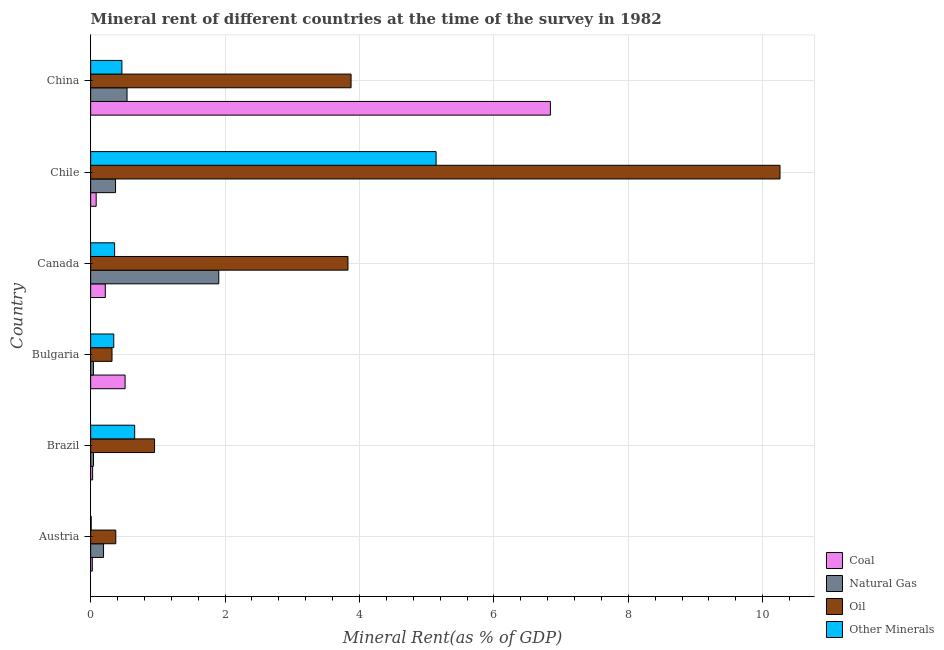How many groups of bars are there?
Keep it short and to the point. 6. Are the number of bars on each tick of the Y-axis equal?
Your answer should be compact. Yes. How many bars are there on the 1st tick from the top?
Your answer should be compact. 4. How many bars are there on the 3rd tick from the bottom?
Give a very brief answer. 4. What is the  rent of other minerals in Bulgaria?
Make the answer very short. 0.34. Across all countries, what is the maximum natural gas rent?
Your answer should be very brief. 1.91. Across all countries, what is the minimum coal rent?
Ensure brevity in your answer.  0.02. In which country was the coal rent maximum?
Keep it short and to the point. China. What is the total coal rent in the graph?
Your answer should be compact. 7.71. What is the difference between the coal rent in Austria and that in Canada?
Provide a short and direct response. -0.19. What is the difference between the oil rent in Brazil and the  rent of other minerals in Canada?
Provide a short and direct response. 0.59. What is the average coal rent per country?
Offer a very short reply. 1.28. What is the difference between the oil rent and coal rent in China?
Your answer should be very brief. -2.97. In how many countries, is the oil rent greater than 2 %?
Your answer should be compact. 3. What is the ratio of the  rent of other minerals in Austria to that in Chile?
Make the answer very short. 0. What is the difference between the highest and the second highest  rent of other minerals?
Your answer should be compact. 4.49. What is the difference between the highest and the lowest oil rent?
Offer a very short reply. 9.94. In how many countries, is the natural gas rent greater than the average natural gas rent taken over all countries?
Offer a terse response. 2. Is the sum of the natural gas rent in Austria and Chile greater than the maximum coal rent across all countries?
Provide a short and direct response. No. Is it the case that in every country, the sum of the oil rent and  rent of other minerals is greater than the sum of coal rent and natural gas rent?
Give a very brief answer. No. What does the 2nd bar from the top in Chile represents?
Ensure brevity in your answer.  Oil. What does the 1st bar from the bottom in Brazil represents?
Give a very brief answer. Coal. Is it the case that in every country, the sum of the coal rent and natural gas rent is greater than the oil rent?
Give a very brief answer. No. What is the difference between two consecutive major ticks on the X-axis?
Give a very brief answer. 2. Does the graph contain any zero values?
Offer a terse response. No. Where does the legend appear in the graph?
Provide a succinct answer. Bottom right. How many legend labels are there?
Ensure brevity in your answer.  4. How are the legend labels stacked?
Ensure brevity in your answer.  Vertical. What is the title of the graph?
Give a very brief answer. Mineral rent of different countries at the time of the survey in 1982. What is the label or title of the X-axis?
Your answer should be very brief. Mineral Rent(as % of GDP). What is the Mineral Rent(as % of GDP) of Coal in Austria?
Give a very brief answer. 0.02. What is the Mineral Rent(as % of GDP) of Natural Gas in Austria?
Give a very brief answer. 0.19. What is the Mineral Rent(as % of GDP) in Oil in Austria?
Your answer should be compact. 0.37. What is the Mineral Rent(as % of GDP) in Other Minerals in Austria?
Provide a succinct answer. 0.01. What is the Mineral Rent(as % of GDP) in Coal in Brazil?
Offer a terse response. 0.03. What is the Mineral Rent(as % of GDP) of Natural Gas in Brazil?
Make the answer very short. 0.04. What is the Mineral Rent(as % of GDP) in Oil in Brazil?
Provide a short and direct response. 0.95. What is the Mineral Rent(as % of GDP) of Other Minerals in Brazil?
Offer a terse response. 0.66. What is the Mineral Rent(as % of GDP) in Coal in Bulgaria?
Provide a succinct answer. 0.51. What is the Mineral Rent(as % of GDP) of Natural Gas in Bulgaria?
Provide a succinct answer. 0.04. What is the Mineral Rent(as % of GDP) in Oil in Bulgaria?
Offer a very short reply. 0.32. What is the Mineral Rent(as % of GDP) of Other Minerals in Bulgaria?
Give a very brief answer. 0.34. What is the Mineral Rent(as % of GDP) of Coal in Canada?
Your answer should be compact. 0.22. What is the Mineral Rent(as % of GDP) in Natural Gas in Canada?
Provide a short and direct response. 1.91. What is the Mineral Rent(as % of GDP) of Oil in Canada?
Offer a terse response. 3.83. What is the Mineral Rent(as % of GDP) of Other Minerals in Canada?
Provide a succinct answer. 0.36. What is the Mineral Rent(as % of GDP) of Coal in Chile?
Ensure brevity in your answer.  0.08. What is the Mineral Rent(as % of GDP) in Natural Gas in Chile?
Give a very brief answer. 0.37. What is the Mineral Rent(as % of GDP) of Oil in Chile?
Your answer should be compact. 10.26. What is the Mineral Rent(as % of GDP) in Other Minerals in Chile?
Your response must be concise. 5.14. What is the Mineral Rent(as % of GDP) of Coal in China?
Your answer should be very brief. 6.84. What is the Mineral Rent(as % of GDP) of Natural Gas in China?
Your response must be concise. 0.54. What is the Mineral Rent(as % of GDP) of Oil in China?
Your response must be concise. 3.87. What is the Mineral Rent(as % of GDP) in Other Minerals in China?
Make the answer very short. 0.47. Across all countries, what is the maximum Mineral Rent(as % of GDP) in Coal?
Provide a short and direct response. 6.84. Across all countries, what is the maximum Mineral Rent(as % of GDP) in Natural Gas?
Your answer should be very brief. 1.91. Across all countries, what is the maximum Mineral Rent(as % of GDP) in Oil?
Offer a very short reply. 10.26. Across all countries, what is the maximum Mineral Rent(as % of GDP) in Other Minerals?
Offer a terse response. 5.14. Across all countries, what is the minimum Mineral Rent(as % of GDP) of Coal?
Your answer should be very brief. 0.02. Across all countries, what is the minimum Mineral Rent(as % of GDP) in Natural Gas?
Make the answer very short. 0.04. Across all countries, what is the minimum Mineral Rent(as % of GDP) of Oil?
Your answer should be very brief. 0.32. Across all countries, what is the minimum Mineral Rent(as % of GDP) of Other Minerals?
Make the answer very short. 0.01. What is the total Mineral Rent(as % of GDP) in Coal in the graph?
Give a very brief answer. 7.71. What is the total Mineral Rent(as % of GDP) of Natural Gas in the graph?
Your answer should be compact. 3.09. What is the total Mineral Rent(as % of GDP) of Oil in the graph?
Give a very brief answer. 19.6. What is the total Mineral Rent(as % of GDP) of Other Minerals in the graph?
Offer a terse response. 6.97. What is the difference between the Mineral Rent(as % of GDP) of Coal in Austria and that in Brazil?
Offer a very short reply. -0. What is the difference between the Mineral Rent(as % of GDP) of Natural Gas in Austria and that in Brazil?
Make the answer very short. 0.15. What is the difference between the Mineral Rent(as % of GDP) of Oil in Austria and that in Brazil?
Provide a succinct answer. -0.58. What is the difference between the Mineral Rent(as % of GDP) in Other Minerals in Austria and that in Brazil?
Your response must be concise. -0.65. What is the difference between the Mineral Rent(as % of GDP) in Coal in Austria and that in Bulgaria?
Make the answer very short. -0.49. What is the difference between the Mineral Rent(as % of GDP) of Natural Gas in Austria and that in Bulgaria?
Provide a short and direct response. 0.15. What is the difference between the Mineral Rent(as % of GDP) of Oil in Austria and that in Bulgaria?
Ensure brevity in your answer.  0.06. What is the difference between the Mineral Rent(as % of GDP) of Other Minerals in Austria and that in Bulgaria?
Your answer should be very brief. -0.34. What is the difference between the Mineral Rent(as % of GDP) in Coal in Austria and that in Canada?
Provide a short and direct response. -0.19. What is the difference between the Mineral Rent(as % of GDP) in Natural Gas in Austria and that in Canada?
Keep it short and to the point. -1.71. What is the difference between the Mineral Rent(as % of GDP) of Oil in Austria and that in Canada?
Your response must be concise. -3.45. What is the difference between the Mineral Rent(as % of GDP) of Other Minerals in Austria and that in Canada?
Offer a terse response. -0.35. What is the difference between the Mineral Rent(as % of GDP) in Coal in Austria and that in Chile?
Offer a terse response. -0.06. What is the difference between the Mineral Rent(as % of GDP) in Natural Gas in Austria and that in Chile?
Give a very brief answer. -0.18. What is the difference between the Mineral Rent(as % of GDP) of Oil in Austria and that in Chile?
Offer a terse response. -9.88. What is the difference between the Mineral Rent(as % of GDP) in Other Minerals in Austria and that in Chile?
Your response must be concise. -5.13. What is the difference between the Mineral Rent(as % of GDP) in Coal in Austria and that in China?
Make the answer very short. -6.82. What is the difference between the Mineral Rent(as % of GDP) of Natural Gas in Austria and that in China?
Offer a terse response. -0.35. What is the difference between the Mineral Rent(as % of GDP) of Oil in Austria and that in China?
Your answer should be very brief. -3.5. What is the difference between the Mineral Rent(as % of GDP) in Other Minerals in Austria and that in China?
Provide a succinct answer. -0.46. What is the difference between the Mineral Rent(as % of GDP) in Coal in Brazil and that in Bulgaria?
Provide a succinct answer. -0.48. What is the difference between the Mineral Rent(as % of GDP) in Natural Gas in Brazil and that in Bulgaria?
Provide a short and direct response. 0. What is the difference between the Mineral Rent(as % of GDP) of Oil in Brazil and that in Bulgaria?
Your answer should be very brief. 0.63. What is the difference between the Mineral Rent(as % of GDP) in Other Minerals in Brazil and that in Bulgaria?
Ensure brevity in your answer.  0.31. What is the difference between the Mineral Rent(as % of GDP) of Coal in Brazil and that in Canada?
Provide a short and direct response. -0.19. What is the difference between the Mineral Rent(as % of GDP) of Natural Gas in Brazil and that in Canada?
Ensure brevity in your answer.  -1.86. What is the difference between the Mineral Rent(as % of GDP) in Oil in Brazil and that in Canada?
Your answer should be compact. -2.88. What is the difference between the Mineral Rent(as % of GDP) in Other Minerals in Brazil and that in Canada?
Provide a succinct answer. 0.3. What is the difference between the Mineral Rent(as % of GDP) in Coal in Brazil and that in Chile?
Your response must be concise. -0.05. What is the difference between the Mineral Rent(as % of GDP) of Natural Gas in Brazil and that in Chile?
Provide a succinct answer. -0.33. What is the difference between the Mineral Rent(as % of GDP) in Oil in Brazil and that in Chile?
Your answer should be compact. -9.31. What is the difference between the Mineral Rent(as % of GDP) in Other Minerals in Brazil and that in Chile?
Offer a very short reply. -4.49. What is the difference between the Mineral Rent(as % of GDP) in Coal in Brazil and that in China?
Ensure brevity in your answer.  -6.81. What is the difference between the Mineral Rent(as % of GDP) of Natural Gas in Brazil and that in China?
Provide a short and direct response. -0.5. What is the difference between the Mineral Rent(as % of GDP) in Oil in Brazil and that in China?
Offer a terse response. -2.92. What is the difference between the Mineral Rent(as % of GDP) of Other Minerals in Brazil and that in China?
Provide a short and direct response. 0.19. What is the difference between the Mineral Rent(as % of GDP) of Coal in Bulgaria and that in Canada?
Keep it short and to the point. 0.29. What is the difference between the Mineral Rent(as % of GDP) in Natural Gas in Bulgaria and that in Canada?
Your answer should be compact. -1.87. What is the difference between the Mineral Rent(as % of GDP) of Oil in Bulgaria and that in Canada?
Offer a very short reply. -3.51. What is the difference between the Mineral Rent(as % of GDP) of Other Minerals in Bulgaria and that in Canada?
Provide a succinct answer. -0.01. What is the difference between the Mineral Rent(as % of GDP) of Coal in Bulgaria and that in Chile?
Your answer should be compact. 0.43. What is the difference between the Mineral Rent(as % of GDP) of Natural Gas in Bulgaria and that in Chile?
Provide a succinct answer. -0.33. What is the difference between the Mineral Rent(as % of GDP) of Oil in Bulgaria and that in Chile?
Ensure brevity in your answer.  -9.94. What is the difference between the Mineral Rent(as % of GDP) in Other Minerals in Bulgaria and that in Chile?
Your response must be concise. -4.8. What is the difference between the Mineral Rent(as % of GDP) in Coal in Bulgaria and that in China?
Your answer should be compact. -6.33. What is the difference between the Mineral Rent(as % of GDP) of Natural Gas in Bulgaria and that in China?
Offer a terse response. -0.5. What is the difference between the Mineral Rent(as % of GDP) of Oil in Bulgaria and that in China?
Offer a very short reply. -3.56. What is the difference between the Mineral Rent(as % of GDP) of Other Minerals in Bulgaria and that in China?
Your answer should be compact. -0.12. What is the difference between the Mineral Rent(as % of GDP) in Coal in Canada and that in Chile?
Your response must be concise. 0.14. What is the difference between the Mineral Rent(as % of GDP) in Natural Gas in Canada and that in Chile?
Keep it short and to the point. 1.54. What is the difference between the Mineral Rent(as % of GDP) in Oil in Canada and that in Chile?
Provide a short and direct response. -6.43. What is the difference between the Mineral Rent(as % of GDP) in Other Minerals in Canada and that in Chile?
Your answer should be compact. -4.78. What is the difference between the Mineral Rent(as % of GDP) in Coal in Canada and that in China?
Offer a terse response. -6.62. What is the difference between the Mineral Rent(as % of GDP) in Natural Gas in Canada and that in China?
Keep it short and to the point. 1.36. What is the difference between the Mineral Rent(as % of GDP) of Oil in Canada and that in China?
Your response must be concise. -0.05. What is the difference between the Mineral Rent(as % of GDP) of Other Minerals in Canada and that in China?
Your answer should be compact. -0.11. What is the difference between the Mineral Rent(as % of GDP) of Coal in Chile and that in China?
Your answer should be compact. -6.76. What is the difference between the Mineral Rent(as % of GDP) in Natural Gas in Chile and that in China?
Ensure brevity in your answer.  -0.17. What is the difference between the Mineral Rent(as % of GDP) of Oil in Chile and that in China?
Ensure brevity in your answer.  6.38. What is the difference between the Mineral Rent(as % of GDP) of Other Minerals in Chile and that in China?
Offer a very short reply. 4.68. What is the difference between the Mineral Rent(as % of GDP) of Coal in Austria and the Mineral Rent(as % of GDP) of Natural Gas in Brazil?
Provide a succinct answer. -0.02. What is the difference between the Mineral Rent(as % of GDP) in Coal in Austria and the Mineral Rent(as % of GDP) in Oil in Brazil?
Make the answer very short. -0.93. What is the difference between the Mineral Rent(as % of GDP) in Coal in Austria and the Mineral Rent(as % of GDP) in Other Minerals in Brazil?
Your response must be concise. -0.63. What is the difference between the Mineral Rent(as % of GDP) of Natural Gas in Austria and the Mineral Rent(as % of GDP) of Oil in Brazil?
Provide a short and direct response. -0.76. What is the difference between the Mineral Rent(as % of GDP) of Natural Gas in Austria and the Mineral Rent(as % of GDP) of Other Minerals in Brazil?
Offer a terse response. -0.46. What is the difference between the Mineral Rent(as % of GDP) in Oil in Austria and the Mineral Rent(as % of GDP) in Other Minerals in Brazil?
Your response must be concise. -0.28. What is the difference between the Mineral Rent(as % of GDP) of Coal in Austria and the Mineral Rent(as % of GDP) of Natural Gas in Bulgaria?
Provide a short and direct response. -0.02. What is the difference between the Mineral Rent(as % of GDP) of Coal in Austria and the Mineral Rent(as % of GDP) of Oil in Bulgaria?
Provide a succinct answer. -0.29. What is the difference between the Mineral Rent(as % of GDP) of Coal in Austria and the Mineral Rent(as % of GDP) of Other Minerals in Bulgaria?
Provide a short and direct response. -0.32. What is the difference between the Mineral Rent(as % of GDP) in Natural Gas in Austria and the Mineral Rent(as % of GDP) in Oil in Bulgaria?
Ensure brevity in your answer.  -0.13. What is the difference between the Mineral Rent(as % of GDP) of Natural Gas in Austria and the Mineral Rent(as % of GDP) of Other Minerals in Bulgaria?
Offer a very short reply. -0.15. What is the difference between the Mineral Rent(as % of GDP) in Oil in Austria and the Mineral Rent(as % of GDP) in Other Minerals in Bulgaria?
Give a very brief answer. 0.03. What is the difference between the Mineral Rent(as % of GDP) of Coal in Austria and the Mineral Rent(as % of GDP) of Natural Gas in Canada?
Ensure brevity in your answer.  -1.88. What is the difference between the Mineral Rent(as % of GDP) of Coal in Austria and the Mineral Rent(as % of GDP) of Oil in Canada?
Your answer should be compact. -3.8. What is the difference between the Mineral Rent(as % of GDP) in Coal in Austria and the Mineral Rent(as % of GDP) in Other Minerals in Canada?
Ensure brevity in your answer.  -0.33. What is the difference between the Mineral Rent(as % of GDP) in Natural Gas in Austria and the Mineral Rent(as % of GDP) in Oil in Canada?
Provide a succinct answer. -3.64. What is the difference between the Mineral Rent(as % of GDP) in Natural Gas in Austria and the Mineral Rent(as % of GDP) in Other Minerals in Canada?
Provide a short and direct response. -0.16. What is the difference between the Mineral Rent(as % of GDP) of Oil in Austria and the Mineral Rent(as % of GDP) of Other Minerals in Canada?
Ensure brevity in your answer.  0.02. What is the difference between the Mineral Rent(as % of GDP) in Coal in Austria and the Mineral Rent(as % of GDP) in Natural Gas in Chile?
Provide a short and direct response. -0.35. What is the difference between the Mineral Rent(as % of GDP) of Coal in Austria and the Mineral Rent(as % of GDP) of Oil in Chile?
Provide a short and direct response. -10.23. What is the difference between the Mineral Rent(as % of GDP) in Coal in Austria and the Mineral Rent(as % of GDP) in Other Minerals in Chile?
Offer a terse response. -5.12. What is the difference between the Mineral Rent(as % of GDP) of Natural Gas in Austria and the Mineral Rent(as % of GDP) of Oil in Chile?
Provide a short and direct response. -10.07. What is the difference between the Mineral Rent(as % of GDP) in Natural Gas in Austria and the Mineral Rent(as % of GDP) in Other Minerals in Chile?
Offer a very short reply. -4.95. What is the difference between the Mineral Rent(as % of GDP) in Oil in Austria and the Mineral Rent(as % of GDP) in Other Minerals in Chile?
Offer a very short reply. -4.77. What is the difference between the Mineral Rent(as % of GDP) of Coal in Austria and the Mineral Rent(as % of GDP) of Natural Gas in China?
Make the answer very short. -0.52. What is the difference between the Mineral Rent(as % of GDP) in Coal in Austria and the Mineral Rent(as % of GDP) in Oil in China?
Your answer should be very brief. -3.85. What is the difference between the Mineral Rent(as % of GDP) of Coal in Austria and the Mineral Rent(as % of GDP) of Other Minerals in China?
Your response must be concise. -0.44. What is the difference between the Mineral Rent(as % of GDP) of Natural Gas in Austria and the Mineral Rent(as % of GDP) of Oil in China?
Provide a short and direct response. -3.68. What is the difference between the Mineral Rent(as % of GDP) in Natural Gas in Austria and the Mineral Rent(as % of GDP) in Other Minerals in China?
Provide a short and direct response. -0.27. What is the difference between the Mineral Rent(as % of GDP) of Oil in Austria and the Mineral Rent(as % of GDP) of Other Minerals in China?
Your response must be concise. -0.09. What is the difference between the Mineral Rent(as % of GDP) in Coal in Brazil and the Mineral Rent(as % of GDP) in Natural Gas in Bulgaria?
Offer a terse response. -0.01. What is the difference between the Mineral Rent(as % of GDP) of Coal in Brazil and the Mineral Rent(as % of GDP) of Oil in Bulgaria?
Your answer should be compact. -0.29. What is the difference between the Mineral Rent(as % of GDP) of Coal in Brazil and the Mineral Rent(as % of GDP) of Other Minerals in Bulgaria?
Your response must be concise. -0.31. What is the difference between the Mineral Rent(as % of GDP) of Natural Gas in Brazil and the Mineral Rent(as % of GDP) of Oil in Bulgaria?
Your answer should be compact. -0.28. What is the difference between the Mineral Rent(as % of GDP) in Natural Gas in Brazil and the Mineral Rent(as % of GDP) in Other Minerals in Bulgaria?
Ensure brevity in your answer.  -0.3. What is the difference between the Mineral Rent(as % of GDP) in Oil in Brazil and the Mineral Rent(as % of GDP) in Other Minerals in Bulgaria?
Offer a terse response. 0.61. What is the difference between the Mineral Rent(as % of GDP) in Coal in Brazil and the Mineral Rent(as % of GDP) in Natural Gas in Canada?
Ensure brevity in your answer.  -1.88. What is the difference between the Mineral Rent(as % of GDP) of Coal in Brazil and the Mineral Rent(as % of GDP) of Oil in Canada?
Keep it short and to the point. -3.8. What is the difference between the Mineral Rent(as % of GDP) of Coal in Brazil and the Mineral Rent(as % of GDP) of Other Minerals in Canada?
Offer a very short reply. -0.33. What is the difference between the Mineral Rent(as % of GDP) in Natural Gas in Brazil and the Mineral Rent(as % of GDP) in Oil in Canada?
Make the answer very short. -3.79. What is the difference between the Mineral Rent(as % of GDP) of Natural Gas in Brazil and the Mineral Rent(as % of GDP) of Other Minerals in Canada?
Your answer should be very brief. -0.31. What is the difference between the Mineral Rent(as % of GDP) of Oil in Brazil and the Mineral Rent(as % of GDP) of Other Minerals in Canada?
Give a very brief answer. 0.59. What is the difference between the Mineral Rent(as % of GDP) of Coal in Brazil and the Mineral Rent(as % of GDP) of Natural Gas in Chile?
Provide a succinct answer. -0.34. What is the difference between the Mineral Rent(as % of GDP) of Coal in Brazil and the Mineral Rent(as % of GDP) of Oil in Chile?
Offer a very short reply. -10.23. What is the difference between the Mineral Rent(as % of GDP) of Coal in Brazil and the Mineral Rent(as % of GDP) of Other Minerals in Chile?
Give a very brief answer. -5.11. What is the difference between the Mineral Rent(as % of GDP) in Natural Gas in Brazil and the Mineral Rent(as % of GDP) in Oil in Chile?
Your answer should be very brief. -10.21. What is the difference between the Mineral Rent(as % of GDP) of Natural Gas in Brazil and the Mineral Rent(as % of GDP) of Other Minerals in Chile?
Make the answer very short. -5.1. What is the difference between the Mineral Rent(as % of GDP) in Oil in Brazil and the Mineral Rent(as % of GDP) in Other Minerals in Chile?
Provide a short and direct response. -4.19. What is the difference between the Mineral Rent(as % of GDP) in Coal in Brazil and the Mineral Rent(as % of GDP) in Natural Gas in China?
Offer a terse response. -0.51. What is the difference between the Mineral Rent(as % of GDP) in Coal in Brazil and the Mineral Rent(as % of GDP) in Oil in China?
Keep it short and to the point. -3.85. What is the difference between the Mineral Rent(as % of GDP) of Coal in Brazil and the Mineral Rent(as % of GDP) of Other Minerals in China?
Ensure brevity in your answer.  -0.44. What is the difference between the Mineral Rent(as % of GDP) of Natural Gas in Brazil and the Mineral Rent(as % of GDP) of Oil in China?
Your answer should be very brief. -3.83. What is the difference between the Mineral Rent(as % of GDP) of Natural Gas in Brazil and the Mineral Rent(as % of GDP) of Other Minerals in China?
Make the answer very short. -0.42. What is the difference between the Mineral Rent(as % of GDP) in Oil in Brazil and the Mineral Rent(as % of GDP) in Other Minerals in China?
Ensure brevity in your answer.  0.49. What is the difference between the Mineral Rent(as % of GDP) of Coal in Bulgaria and the Mineral Rent(as % of GDP) of Natural Gas in Canada?
Keep it short and to the point. -1.39. What is the difference between the Mineral Rent(as % of GDP) of Coal in Bulgaria and the Mineral Rent(as % of GDP) of Oil in Canada?
Provide a short and direct response. -3.32. What is the difference between the Mineral Rent(as % of GDP) of Coal in Bulgaria and the Mineral Rent(as % of GDP) of Other Minerals in Canada?
Your answer should be compact. 0.16. What is the difference between the Mineral Rent(as % of GDP) of Natural Gas in Bulgaria and the Mineral Rent(as % of GDP) of Oil in Canada?
Your answer should be compact. -3.79. What is the difference between the Mineral Rent(as % of GDP) in Natural Gas in Bulgaria and the Mineral Rent(as % of GDP) in Other Minerals in Canada?
Keep it short and to the point. -0.32. What is the difference between the Mineral Rent(as % of GDP) in Oil in Bulgaria and the Mineral Rent(as % of GDP) in Other Minerals in Canada?
Offer a terse response. -0.04. What is the difference between the Mineral Rent(as % of GDP) of Coal in Bulgaria and the Mineral Rent(as % of GDP) of Natural Gas in Chile?
Give a very brief answer. 0.14. What is the difference between the Mineral Rent(as % of GDP) in Coal in Bulgaria and the Mineral Rent(as % of GDP) in Oil in Chile?
Your response must be concise. -9.74. What is the difference between the Mineral Rent(as % of GDP) of Coal in Bulgaria and the Mineral Rent(as % of GDP) of Other Minerals in Chile?
Provide a short and direct response. -4.63. What is the difference between the Mineral Rent(as % of GDP) in Natural Gas in Bulgaria and the Mineral Rent(as % of GDP) in Oil in Chile?
Keep it short and to the point. -10.22. What is the difference between the Mineral Rent(as % of GDP) in Natural Gas in Bulgaria and the Mineral Rent(as % of GDP) in Other Minerals in Chile?
Provide a short and direct response. -5.1. What is the difference between the Mineral Rent(as % of GDP) of Oil in Bulgaria and the Mineral Rent(as % of GDP) of Other Minerals in Chile?
Your answer should be compact. -4.82. What is the difference between the Mineral Rent(as % of GDP) in Coal in Bulgaria and the Mineral Rent(as % of GDP) in Natural Gas in China?
Keep it short and to the point. -0.03. What is the difference between the Mineral Rent(as % of GDP) of Coal in Bulgaria and the Mineral Rent(as % of GDP) of Oil in China?
Your answer should be compact. -3.36. What is the difference between the Mineral Rent(as % of GDP) in Coal in Bulgaria and the Mineral Rent(as % of GDP) in Other Minerals in China?
Your answer should be compact. 0.05. What is the difference between the Mineral Rent(as % of GDP) in Natural Gas in Bulgaria and the Mineral Rent(as % of GDP) in Oil in China?
Provide a succinct answer. -3.83. What is the difference between the Mineral Rent(as % of GDP) in Natural Gas in Bulgaria and the Mineral Rent(as % of GDP) in Other Minerals in China?
Provide a short and direct response. -0.42. What is the difference between the Mineral Rent(as % of GDP) of Oil in Bulgaria and the Mineral Rent(as % of GDP) of Other Minerals in China?
Your response must be concise. -0.15. What is the difference between the Mineral Rent(as % of GDP) in Coal in Canada and the Mineral Rent(as % of GDP) in Natural Gas in Chile?
Offer a terse response. -0.15. What is the difference between the Mineral Rent(as % of GDP) of Coal in Canada and the Mineral Rent(as % of GDP) of Oil in Chile?
Ensure brevity in your answer.  -10.04. What is the difference between the Mineral Rent(as % of GDP) in Coal in Canada and the Mineral Rent(as % of GDP) in Other Minerals in Chile?
Offer a very short reply. -4.92. What is the difference between the Mineral Rent(as % of GDP) of Natural Gas in Canada and the Mineral Rent(as % of GDP) of Oil in Chile?
Offer a terse response. -8.35. What is the difference between the Mineral Rent(as % of GDP) in Natural Gas in Canada and the Mineral Rent(as % of GDP) in Other Minerals in Chile?
Keep it short and to the point. -3.23. What is the difference between the Mineral Rent(as % of GDP) in Oil in Canada and the Mineral Rent(as % of GDP) in Other Minerals in Chile?
Provide a succinct answer. -1.31. What is the difference between the Mineral Rent(as % of GDP) of Coal in Canada and the Mineral Rent(as % of GDP) of Natural Gas in China?
Give a very brief answer. -0.32. What is the difference between the Mineral Rent(as % of GDP) in Coal in Canada and the Mineral Rent(as % of GDP) in Oil in China?
Give a very brief answer. -3.66. What is the difference between the Mineral Rent(as % of GDP) in Coal in Canada and the Mineral Rent(as % of GDP) in Other Minerals in China?
Your answer should be compact. -0.25. What is the difference between the Mineral Rent(as % of GDP) in Natural Gas in Canada and the Mineral Rent(as % of GDP) in Oil in China?
Your answer should be very brief. -1.97. What is the difference between the Mineral Rent(as % of GDP) in Natural Gas in Canada and the Mineral Rent(as % of GDP) in Other Minerals in China?
Provide a succinct answer. 1.44. What is the difference between the Mineral Rent(as % of GDP) in Oil in Canada and the Mineral Rent(as % of GDP) in Other Minerals in China?
Provide a succinct answer. 3.36. What is the difference between the Mineral Rent(as % of GDP) in Coal in Chile and the Mineral Rent(as % of GDP) in Natural Gas in China?
Your answer should be compact. -0.46. What is the difference between the Mineral Rent(as % of GDP) in Coal in Chile and the Mineral Rent(as % of GDP) in Oil in China?
Your answer should be very brief. -3.79. What is the difference between the Mineral Rent(as % of GDP) in Coal in Chile and the Mineral Rent(as % of GDP) in Other Minerals in China?
Give a very brief answer. -0.38. What is the difference between the Mineral Rent(as % of GDP) in Natural Gas in Chile and the Mineral Rent(as % of GDP) in Oil in China?
Offer a very short reply. -3.5. What is the difference between the Mineral Rent(as % of GDP) of Natural Gas in Chile and the Mineral Rent(as % of GDP) of Other Minerals in China?
Offer a very short reply. -0.09. What is the difference between the Mineral Rent(as % of GDP) in Oil in Chile and the Mineral Rent(as % of GDP) in Other Minerals in China?
Your answer should be very brief. 9.79. What is the average Mineral Rent(as % of GDP) of Coal per country?
Provide a succinct answer. 1.28. What is the average Mineral Rent(as % of GDP) in Natural Gas per country?
Ensure brevity in your answer.  0.52. What is the average Mineral Rent(as % of GDP) of Oil per country?
Your answer should be compact. 3.27. What is the average Mineral Rent(as % of GDP) in Other Minerals per country?
Provide a short and direct response. 1.16. What is the difference between the Mineral Rent(as % of GDP) of Coal and Mineral Rent(as % of GDP) of Natural Gas in Austria?
Your answer should be very brief. -0.17. What is the difference between the Mineral Rent(as % of GDP) of Coal and Mineral Rent(as % of GDP) of Oil in Austria?
Provide a succinct answer. -0.35. What is the difference between the Mineral Rent(as % of GDP) in Coal and Mineral Rent(as % of GDP) in Other Minerals in Austria?
Ensure brevity in your answer.  0.02. What is the difference between the Mineral Rent(as % of GDP) of Natural Gas and Mineral Rent(as % of GDP) of Oil in Austria?
Keep it short and to the point. -0.18. What is the difference between the Mineral Rent(as % of GDP) of Natural Gas and Mineral Rent(as % of GDP) of Other Minerals in Austria?
Make the answer very short. 0.18. What is the difference between the Mineral Rent(as % of GDP) of Oil and Mineral Rent(as % of GDP) of Other Minerals in Austria?
Ensure brevity in your answer.  0.37. What is the difference between the Mineral Rent(as % of GDP) in Coal and Mineral Rent(as % of GDP) in Natural Gas in Brazil?
Give a very brief answer. -0.01. What is the difference between the Mineral Rent(as % of GDP) in Coal and Mineral Rent(as % of GDP) in Oil in Brazil?
Give a very brief answer. -0.92. What is the difference between the Mineral Rent(as % of GDP) in Coal and Mineral Rent(as % of GDP) in Other Minerals in Brazil?
Ensure brevity in your answer.  -0.63. What is the difference between the Mineral Rent(as % of GDP) of Natural Gas and Mineral Rent(as % of GDP) of Oil in Brazil?
Keep it short and to the point. -0.91. What is the difference between the Mineral Rent(as % of GDP) of Natural Gas and Mineral Rent(as % of GDP) of Other Minerals in Brazil?
Your answer should be compact. -0.61. What is the difference between the Mineral Rent(as % of GDP) of Oil and Mineral Rent(as % of GDP) of Other Minerals in Brazil?
Offer a terse response. 0.3. What is the difference between the Mineral Rent(as % of GDP) of Coal and Mineral Rent(as % of GDP) of Natural Gas in Bulgaria?
Your answer should be very brief. 0.47. What is the difference between the Mineral Rent(as % of GDP) of Coal and Mineral Rent(as % of GDP) of Oil in Bulgaria?
Your answer should be compact. 0.19. What is the difference between the Mineral Rent(as % of GDP) of Coal and Mineral Rent(as % of GDP) of Other Minerals in Bulgaria?
Make the answer very short. 0.17. What is the difference between the Mineral Rent(as % of GDP) in Natural Gas and Mineral Rent(as % of GDP) in Oil in Bulgaria?
Keep it short and to the point. -0.28. What is the difference between the Mineral Rent(as % of GDP) of Natural Gas and Mineral Rent(as % of GDP) of Other Minerals in Bulgaria?
Make the answer very short. -0.3. What is the difference between the Mineral Rent(as % of GDP) of Oil and Mineral Rent(as % of GDP) of Other Minerals in Bulgaria?
Ensure brevity in your answer.  -0.03. What is the difference between the Mineral Rent(as % of GDP) in Coal and Mineral Rent(as % of GDP) in Natural Gas in Canada?
Ensure brevity in your answer.  -1.69. What is the difference between the Mineral Rent(as % of GDP) of Coal and Mineral Rent(as % of GDP) of Oil in Canada?
Provide a succinct answer. -3.61. What is the difference between the Mineral Rent(as % of GDP) in Coal and Mineral Rent(as % of GDP) in Other Minerals in Canada?
Provide a succinct answer. -0.14. What is the difference between the Mineral Rent(as % of GDP) in Natural Gas and Mineral Rent(as % of GDP) in Oil in Canada?
Your answer should be compact. -1.92. What is the difference between the Mineral Rent(as % of GDP) of Natural Gas and Mineral Rent(as % of GDP) of Other Minerals in Canada?
Give a very brief answer. 1.55. What is the difference between the Mineral Rent(as % of GDP) in Oil and Mineral Rent(as % of GDP) in Other Minerals in Canada?
Offer a very short reply. 3.47. What is the difference between the Mineral Rent(as % of GDP) of Coal and Mineral Rent(as % of GDP) of Natural Gas in Chile?
Keep it short and to the point. -0.29. What is the difference between the Mineral Rent(as % of GDP) of Coal and Mineral Rent(as % of GDP) of Oil in Chile?
Ensure brevity in your answer.  -10.18. What is the difference between the Mineral Rent(as % of GDP) of Coal and Mineral Rent(as % of GDP) of Other Minerals in Chile?
Make the answer very short. -5.06. What is the difference between the Mineral Rent(as % of GDP) of Natural Gas and Mineral Rent(as % of GDP) of Oil in Chile?
Your answer should be compact. -9.89. What is the difference between the Mineral Rent(as % of GDP) of Natural Gas and Mineral Rent(as % of GDP) of Other Minerals in Chile?
Keep it short and to the point. -4.77. What is the difference between the Mineral Rent(as % of GDP) of Oil and Mineral Rent(as % of GDP) of Other Minerals in Chile?
Make the answer very short. 5.12. What is the difference between the Mineral Rent(as % of GDP) in Coal and Mineral Rent(as % of GDP) in Natural Gas in China?
Your answer should be compact. 6.3. What is the difference between the Mineral Rent(as % of GDP) of Coal and Mineral Rent(as % of GDP) of Oil in China?
Provide a short and direct response. 2.97. What is the difference between the Mineral Rent(as % of GDP) in Coal and Mineral Rent(as % of GDP) in Other Minerals in China?
Ensure brevity in your answer.  6.38. What is the difference between the Mineral Rent(as % of GDP) of Natural Gas and Mineral Rent(as % of GDP) of Oil in China?
Your response must be concise. -3.33. What is the difference between the Mineral Rent(as % of GDP) of Natural Gas and Mineral Rent(as % of GDP) of Other Minerals in China?
Your answer should be compact. 0.08. What is the difference between the Mineral Rent(as % of GDP) of Oil and Mineral Rent(as % of GDP) of Other Minerals in China?
Give a very brief answer. 3.41. What is the ratio of the Mineral Rent(as % of GDP) in Coal in Austria to that in Brazil?
Provide a short and direct response. 0.84. What is the ratio of the Mineral Rent(as % of GDP) in Natural Gas in Austria to that in Brazil?
Give a very brief answer. 4.52. What is the ratio of the Mineral Rent(as % of GDP) in Oil in Austria to that in Brazil?
Ensure brevity in your answer.  0.39. What is the ratio of the Mineral Rent(as % of GDP) of Other Minerals in Austria to that in Brazil?
Give a very brief answer. 0.01. What is the ratio of the Mineral Rent(as % of GDP) of Coal in Austria to that in Bulgaria?
Provide a short and direct response. 0.05. What is the ratio of the Mineral Rent(as % of GDP) in Natural Gas in Austria to that in Bulgaria?
Ensure brevity in your answer.  4.67. What is the ratio of the Mineral Rent(as % of GDP) of Oil in Austria to that in Bulgaria?
Keep it short and to the point. 1.18. What is the ratio of the Mineral Rent(as % of GDP) of Other Minerals in Austria to that in Bulgaria?
Give a very brief answer. 0.02. What is the ratio of the Mineral Rent(as % of GDP) in Coal in Austria to that in Canada?
Give a very brief answer. 0.11. What is the ratio of the Mineral Rent(as % of GDP) of Natural Gas in Austria to that in Canada?
Make the answer very short. 0.1. What is the ratio of the Mineral Rent(as % of GDP) in Oil in Austria to that in Canada?
Give a very brief answer. 0.1. What is the ratio of the Mineral Rent(as % of GDP) in Other Minerals in Austria to that in Canada?
Ensure brevity in your answer.  0.02. What is the ratio of the Mineral Rent(as % of GDP) in Natural Gas in Austria to that in Chile?
Provide a short and direct response. 0.52. What is the ratio of the Mineral Rent(as % of GDP) of Oil in Austria to that in Chile?
Ensure brevity in your answer.  0.04. What is the ratio of the Mineral Rent(as % of GDP) in Other Minerals in Austria to that in Chile?
Give a very brief answer. 0. What is the ratio of the Mineral Rent(as % of GDP) in Coal in Austria to that in China?
Give a very brief answer. 0. What is the ratio of the Mineral Rent(as % of GDP) in Natural Gas in Austria to that in China?
Make the answer very short. 0.35. What is the ratio of the Mineral Rent(as % of GDP) of Oil in Austria to that in China?
Make the answer very short. 0.1. What is the ratio of the Mineral Rent(as % of GDP) of Other Minerals in Austria to that in China?
Keep it short and to the point. 0.02. What is the ratio of the Mineral Rent(as % of GDP) in Coal in Brazil to that in Bulgaria?
Offer a terse response. 0.06. What is the ratio of the Mineral Rent(as % of GDP) of Natural Gas in Brazil to that in Bulgaria?
Make the answer very short. 1.03. What is the ratio of the Mineral Rent(as % of GDP) in Oil in Brazil to that in Bulgaria?
Ensure brevity in your answer.  2.99. What is the ratio of the Mineral Rent(as % of GDP) in Other Minerals in Brazil to that in Bulgaria?
Your response must be concise. 1.91. What is the ratio of the Mineral Rent(as % of GDP) of Coal in Brazil to that in Canada?
Your answer should be compact. 0.13. What is the ratio of the Mineral Rent(as % of GDP) in Natural Gas in Brazil to that in Canada?
Offer a very short reply. 0.02. What is the ratio of the Mineral Rent(as % of GDP) in Oil in Brazil to that in Canada?
Ensure brevity in your answer.  0.25. What is the ratio of the Mineral Rent(as % of GDP) of Other Minerals in Brazil to that in Canada?
Provide a succinct answer. 1.84. What is the ratio of the Mineral Rent(as % of GDP) of Coal in Brazil to that in Chile?
Ensure brevity in your answer.  0.36. What is the ratio of the Mineral Rent(as % of GDP) in Natural Gas in Brazil to that in Chile?
Keep it short and to the point. 0.11. What is the ratio of the Mineral Rent(as % of GDP) of Oil in Brazil to that in Chile?
Ensure brevity in your answer.  0.09. What is the ratio of the Mineral Rent(as % of GDP) in Other Minerals in Brazil to that in Chile?
Give a very brief answer. 0.13. What is the ratio of the Mineral Rent(as % of GDP) of Coal in Brazil to that in China?
Provide a short and direct response. 0. What is the ratio of the Mineral Rent(as % of GDP) in Natural Gas in Brazil to that in China?
Give a very brief answer. 0.08. What is the ratio of the Mineral Rent(as % of GDP) in Oil in Brazil to that in China?
Give a very brief answer. 0.25. What is the ratio of the Mineral Rent(as % of GDP) in Other Minerals in Brazil to that in China?
Keep it short and to the point. 1.41. What is the ratio of the Mineral Rent(as % of GDP) in Coal in Bulgaria to that in Canada?
Offer a very short reply. 2.35. What is the ratio of the Mineral Rent(as % of GDP) in Natural Gas in Bulgaria to that in Canada?
Your answer should be compact. 0.02. What is the ratio of the Mineral Rent(as % of GDP) in Oil in Bulgaria to that in Canada?
Your response must be concise. 0.08. What is the ratio of the Mineral Rent(as % of GDP) of Other Minerals in Bulgaria to that in Canada?
Provide a short and direct response. 0.96. What is the ratio of the Mineral Rent(as % of GDP) in Coal in Bulgaria to that in Chile?
Your response must be concise. 6.24. What is the ratio of the Mineral Rent(as % of GDP) in Natural Gas in Bulgaria to that in Chile?
Keep it short and to the point. 0.11. What is the ratio of the Mineral Rent(as % of GDP) in Oil in Bulgaria to that in Chile?
Your answer should be very brief. 0.03. What is the ratio of the Mineral Rent(as % of GDP) in Other Minerals in Bulgaria to that in Chile?
Make the answer very short. 0.07. What is the ratio of the Mineral Rent(as % of GDP) in Coal in Bulgaria to that in China?
Offer a very short reply. 0.07. What is the ratio of the Mineral Rent(as % of GDP) in Natural Gas in Bulgaria to that in China?
Give a very brief answer. 0.08. What is the ratio of the Mineral Rent(as % of GDP) of Oil in Bulgaria to that in China?
Make the answer very short. 0.08. What is the ratio of the Mineral Rent(as % of GDP) of Other Minerals in Bulgaria to that in China?
Offer a very short reply. 0.74. What is the ratio of the Mineral Rent(as % of GDP) of Coal in Canada to that in Chile?
Make the answer very short. 2.66. What is the ratio of the Mineral Rent(as % of GDP) in Natural Gas in Canada to that in Chile?
Keep it short and to the point. 5.15. What is the ratio of the Mineral Rent(as % of GDP) of Oil in Canada to that in Chile?
Keep it short and to the point. 0.37. What is the ratio of the Mineral Rent(as % of GDP) in Other Minerals in Canada to that in Chile?
Ensure brevity in your answer.  0.07. What is the ratio of the Mineral Rent(as % of GDP) in Coal in Canada to that in China?
Your answer should be compact. 0.03. What is the ratio of the Mineral Rent(as % of GDP) in Natural Gas in Canada to that in China?
Your answer should be very brief. 3.52. What is the ratio of the Mineral Rent(as % of GDP) in Oil in Canada to that in China?
Offer a very short reply. 0.99. What is the ratio of the Mineral Rent(as % of GDP) in Other Minerals in Canada to that in China?
Offer a terse response. 0.77. What is the ratio of the Mineral Rent(as % of GDP) in Coal in Chile to that in China?
Offer a terse response. 0.01. What is the ratio of the Mineral Rent(as % of GDP) in Natural Gas in Chile to that in China?
Provide a short and direct response. 0.68. What is the ratio of the Mineral Rent(as % of GDP) in Oil in Chile to that in China?
Your response must be concise. 2.65. What is the ratio of the Mineral Rent(as % of GDP) in Other Minerals in Chile to that in China?
Provide a short and direct response. 11.05. What is the difference between the highest and the second highest Mineral Rent(as % of GDP) of Coal?
Your answer should be very brief. 6.33. What is the difference between the highest and the second highest Mineral Rent(as % of GDP) in Natural Gas?
Provide a succinct answer. 1.36. What is the difference between the highest and the second highest Mineral Rent(as % of GDP) in Oil?
Ensure brevity in your answer.  6.38. What is the difference between the highest and the second highest Mineral Rent(as % of GDP) in Other Minerals?
Your answer should be very brief. 4.49. What is the difference between the highest and the lowest Mineral Rent(as % of GDP) of Coal?
Provide a short and direct response. 6.82. What is the difference between the highest and the lowest Mineral Rent(as % of GDP) in Natural Gas?
Keep it short and to the point. 1.87. What is the difference between the highest and the lowest Mineral Rent(as % of GDP) in Oil?
Your answer should be compact. 9.94. What is the difference between the highest and the lowest Mineral Rent(as % of GDP) of Other Minerals?
Ensure brevity in your answer.  5.13. 